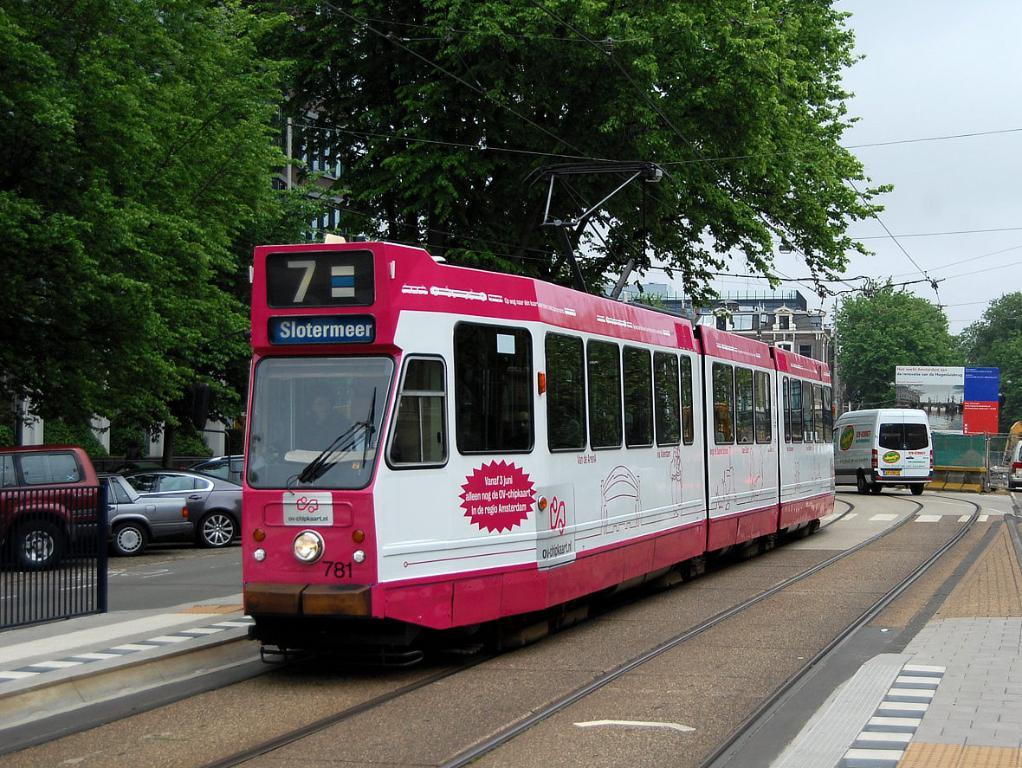<image>
Offer a succinct explanation of the picture presented. A red and white train that says Slotermeer on the front is going down a city street. 